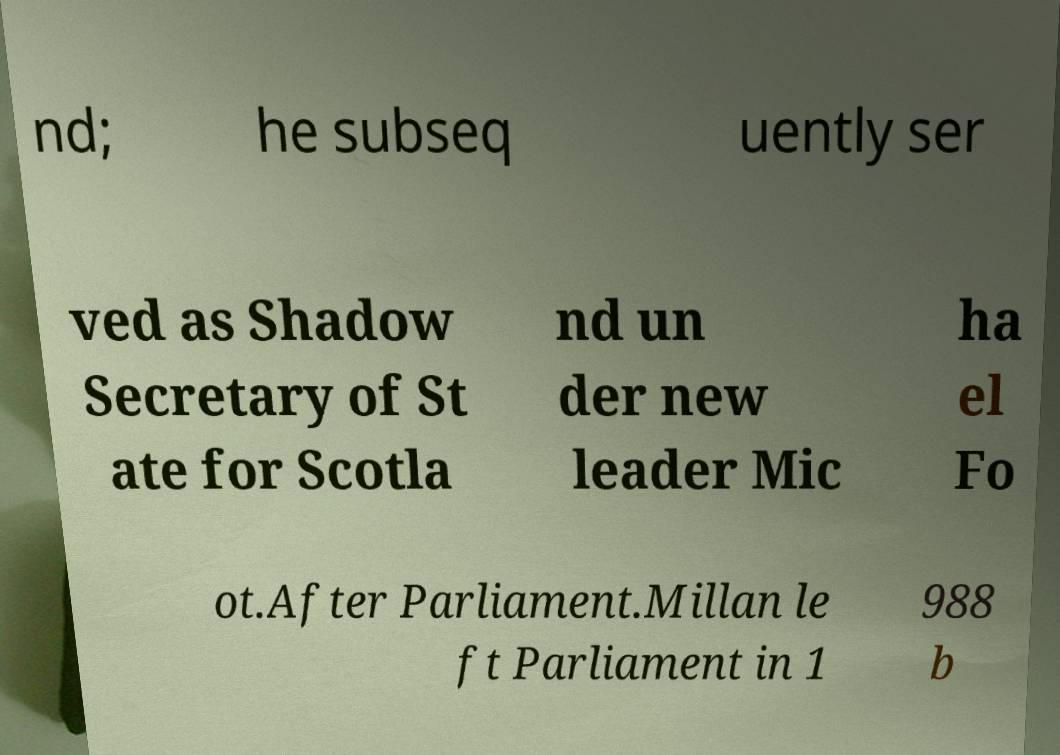Can you accurately transcribe the text from the provided image for me? nd; he subseq uently ser ved as Shadow Secretary of St ate for Scotla nd un der new leader Mic ha el Fo ot.After Parliament.Millan le ft Parliament in 1 988 b 